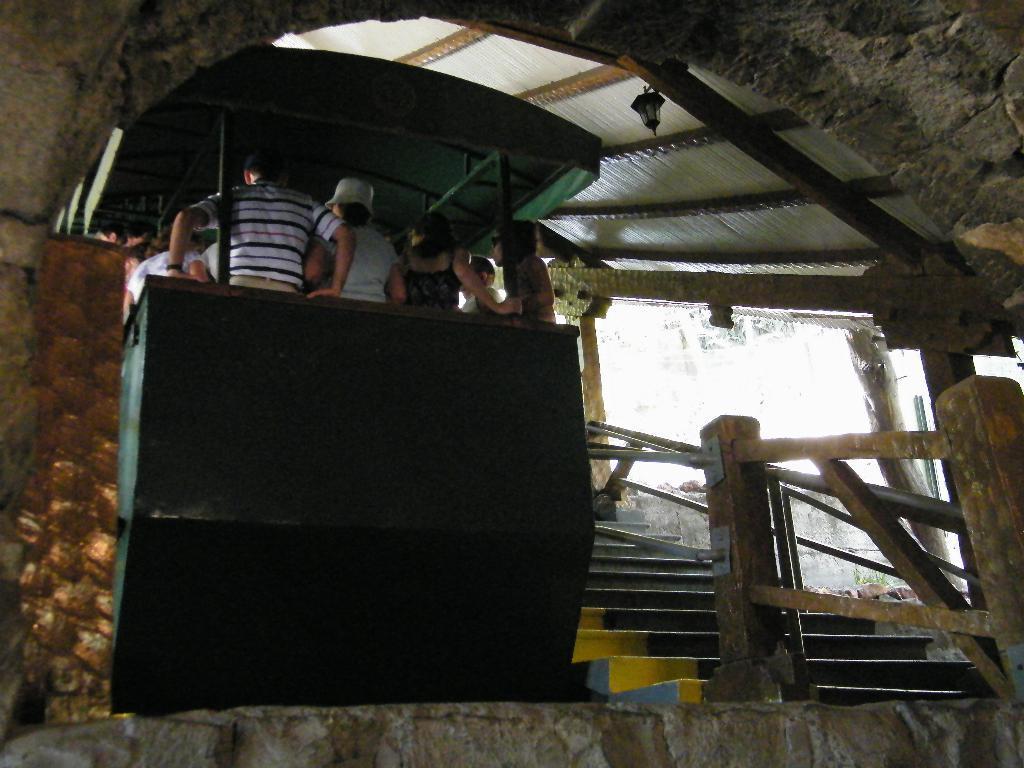Could you give a brief overview of what you see in this image? In the middle of the image few people are standing. Beside them there are some steps and fencing. At the top of the image there is roof. 